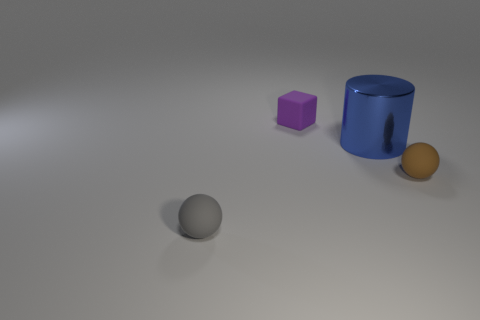There is a tiny matte sphere that is on the right side of the ball on the left side of the purple rubber thing; are there any large objects in front of it?
Give a very brief answer. No. What number of gray objects have the same material as the tiny brown sphere?
Provide a short and direct response. 1. Does the matte ball that is right of the big metallic cylinder have the same size as the rubber thing that is in front of the brown ball?
Your answer should be very brief. Yes. There is a small rubber ball that is left of the blue thing that is right of the small gray matte sphere that is in front of the purple matte thing; what color is it?
Keep it short and to the point. Gray. Are there any other tiny things that have the same shape as the tiny purple thing?
Your answer should be very brief. No. Is the number of balls on the left side of the tiny matte block the same as the number of small matte cubes that are in front of the large object?
Provide a succinct answer. No. There is a thing left of the purple rubber object; is its shape the same as the brown thing?
Your answer should be very brief. Yes. Does the big thing have the same shape as the brown thing?
Ensure brevity in your answer.  No. How many matte things are small brown things or small cubes?
Offer a very short reply. 2. Is the gray rubber thing the same size as the rubber cube?
Offer a terse response. Yes. 